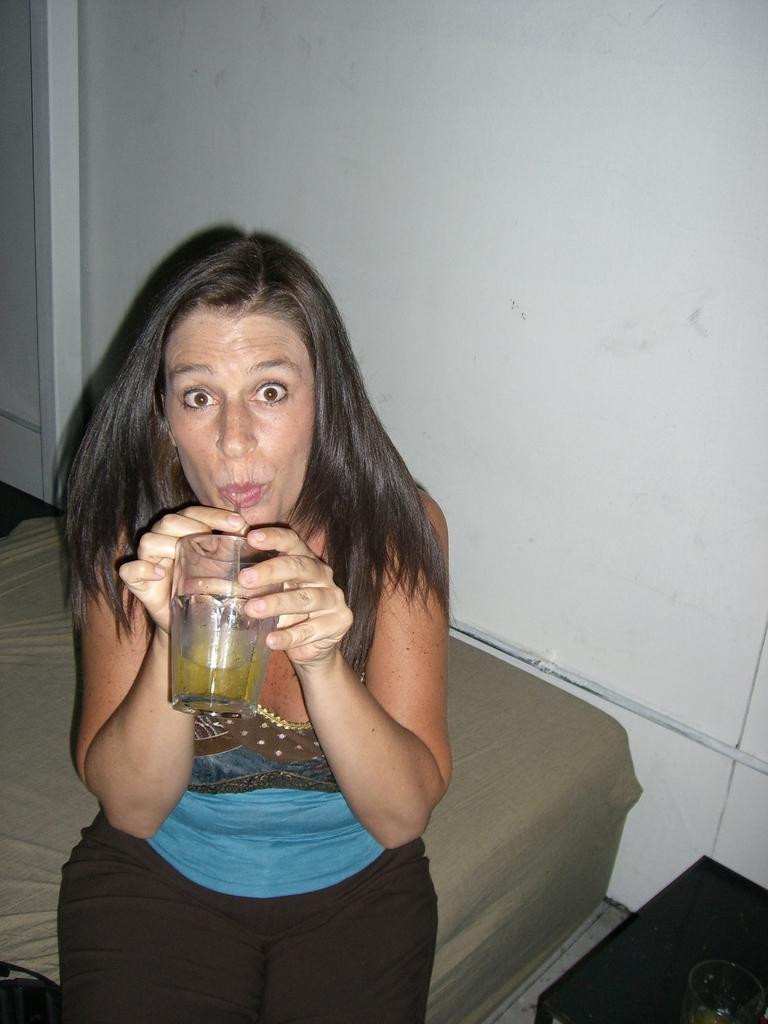Can you describe this image briefly? In this image I can see the person with the dress and holding the glass. I can see the person sitting on the bed. To the right I can see the glass on the table. I can see the white background. 